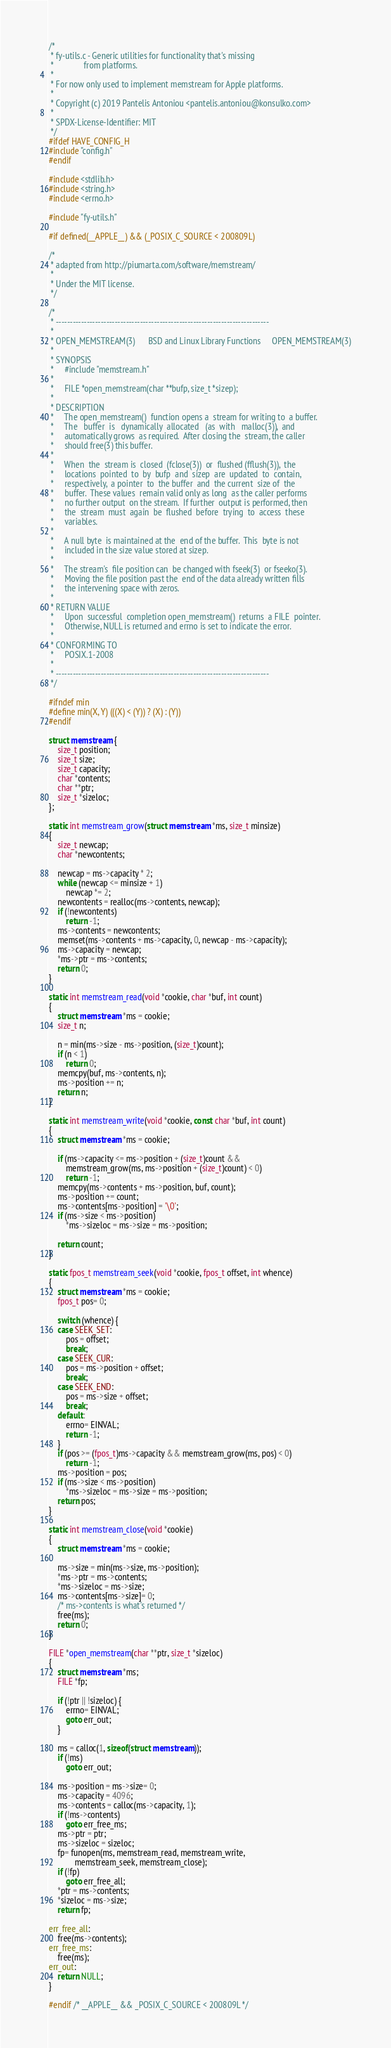Convert code to text. <code><loc_0><loc_0><loc_500><loc_500><_C_>/*
 * fy-utils.c - Generic utilities for functionality that's missing
 *              from platforms.
 *
 * For now only used to implement memstream for Apple platforms.
 *
 * Copyright (c) 2019 Pantelis Antoniou <pantelis.antoniou@konsulko.com>
 *
 * SPDX-License-Identifier: MIT
 */
#ifdef HAVE_CONFIG_H
#include "config.h"
#endif

#include <stdlib.h>
#include <string.h>
#include <errno.h>

#include "fy-utils.h"

#if defined(__APPLE__) && (_POSIX_C_SOURCE < 200809L)

/*
 * adapted from http://piumarta.com/software/memstream/
 *
 * Under the MIT license.
 */

/*
 * ----------------------------------------------------------------------------
 *
 * OPEN_MEMSTREAM(3)      BSD and Linux Library Functions     OPEN_MEMSTREAM(3)
 *
 * SYNOPSIS
 *     #include "memstream.h"
 *
 *     FILE *open_memstream(char **bufp, size_t *sizep);
 *
 * DESCRIPTION
 *     The open_memstream()  function opens a  stream for writing to  a buffer.
 *     The   buffer  is   dynamically  allocated   (as  with   malloc(3)),  and
 *     automatically grows  as required.  After closing the  stream, the caller
 *     should free(3) this buffer.
 *
 *     When  the  stream is  closed  (fclose(3))  or  flushed (fflush(3)),  the
 *     locations  pointed  to  by  bufp  and  sizep  are  updated  to  contain,
 *     respectively,  a pointer  to  the buffer  and  the current  size of  the
 *     buffer.  These values  remain valid only as long  as the caller performs
 *     no further output  on the stream.  If further  output is performed, then
 *     the  stream  must  again  be  flushed  before  trying  to  access  these
 *     variables.
 *
 *     A null byte  is maintained at the  end of the buffer.  This  byte is not
 *     included in the size value stored at sizep.
 *
 *     The stream's  file position can  be changed with fseek(3)  or fseeko(3).
 *     Moving the file position past the  end of the data already written fills
 *     the intervening space with zeros.
 *
 * RETURN VALUE
 *     Upon  successful  completion open_memstream()  returns  a FILE  pointer.
 *     Otherwise, NULL is returned and errno is set to indicate the error.
 *
 * CONFORMING TO
 *     POSIX.1-2008
 *
 * ----------------------------------------------------------------------------
 */

#ifndef min
#define min(X, Y) (((X) < (Y)) ? (X) : (Y))
#endif

struct memstream {
	size_t position;
	size_t size;
	size_t capacity;
	char *contents;
	char **ptr;
	size_t *sizeloc;
};

static int memstream_grow(struct memstream *ms, size_t minsize)
{
	size_t newcap;
	char *newcontents;

	newcap = ms->capacity * 2;
	while (newcap <= minsize + 1)
		newcap *= 2;
	newcontents = realloc(ms->contents, newcap);
	if (!newcontents)
		return -1;
	ms->contents = newcontents;
	memset(ms->contents + ms->capacity, 0, newcap - ms->capacity);
	ms->capacity = newcap;
	*ms->ptr = ms->contents;
	return 0;
}

static int memstream_read(void *cookie, char *buf, int count)
{
	struct memstream *ms = cookie;
	size_t n;

	n = min(ms->size - ms->position, (size_t)count);
	if (n < 1)
		return 0;
	memcpy(buf, ms->contents, n);
	ms->position += n;
	return n;
}

static int memstream_write(void *cookie, const char *buf, int count)
{
	struct memstream *ms = cookie;

	if (ms->capacity <= ms->position + (size_t)count &&
	    memstream_grow(ms, ms->position + (size_t)count) < 0)
		return -1;
	memcpy(ms->contents + ms->position, buf, count);
	ms->position += count;
	ms->contents[ms->position] = '\0';
	if (ms->size < ms->position)
		*ms->sizeloc = ms->size = ms->position;

	return count;
}

static fpos_t memstream_seek(void *cookie, fpos_t offset, int whence)
{
	struct memstream *ms = cookie;
	fpos_t pos= 0;

	switch (whence) {
	case SEEK_SET:
		pos = offset;
		break;
	case SEEK_CUR:
		pos = ms->position + offset;
		break;
	case SEEK_END:
		pos = ms->size + offset;
		break;
	default:
		errno= EINVAL;
		return -1;
	}
	if (pos >= (fpos_t)ms->capacity && memstream_grow(ms, pos) < 0)
		return -1;
	ms->position = pos;
	if (ms->size < ms->position)
		*ms->sizeloc = ms->size = ms->position;
	return pos;
}

static int memstream_close(void *cookie)
{
	struct memstream *ms = cookie;

	ms->size = min(ms->size, ms->position);
	*ms->ptr = ms->contents;
	*ms->sizeloc = ms->size;
	ms->contents[ms->size]= 0;
	/* ms->contents is what's returned */
	free(ms);
	return 0;
}

FILE *open_memstream(char **ptr, size_t *sizeloc)
{
	struct memstream *ms;
	FILE *fp;

	if (!ptr || !sizeloc) {
		errno= EINVAL;
		goto err_out;
	}

	ms = calloc(1, sizeof(struct memstream));
	if (!ms)
		goto err_out;

	ms->position = ms->size= 0;
	ms->capacity = 4096;
	ms->contents = calloc(ms->capacity, 1);
	if (!ms->contents)
		goto err_free_ms;
	ms->ptr = ptr;
	ms->sizeloc = sizeloc;
	fp= funopen(ms, memstream_read, memstream_write,
			memstream_seek, memstream_close);
	if (!fp)
		goto err_free_all;
	*ptr = ms->contents;
	*sizeloc = ms->size;
	return fp;

err_free_all:
	free(ms->contents);
err_free_ms:
	free(ms);
err_out:
	return NULL;
}

#endif /* __APPLE__ && _POSIX_C_SOURCE < 200809L */
</code> 